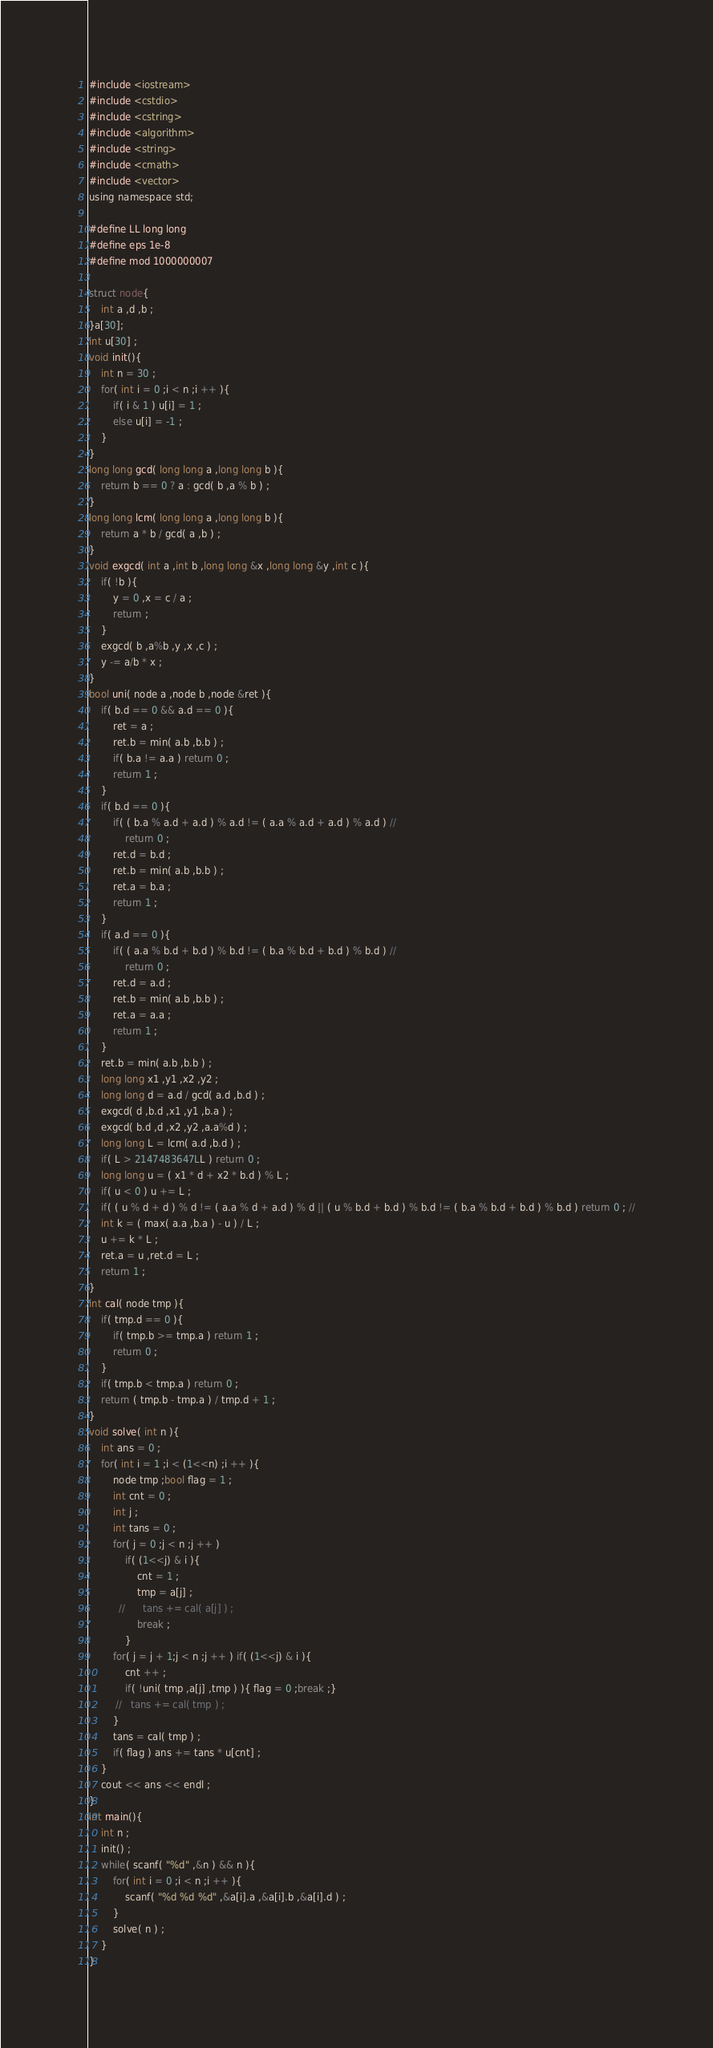<code> <loc_0><loc_0><loc_500><loc_500><_C_>








#include <iostream>
#include <cstdio>
#include <cstring>
#include <algorithm>
#include <string>
#include <cmath>
#include <vector>
using namespace std;

#define LL long long
#define eps 1e-8
#define mod 1000000007

struct node{
    int a ,d ,b ;
}a[30];
int u[30] ;
void init(){
    int n = 30 ;
    for( int i = 0 ;i < n ;i ++ ){
        if( i & 1 ) u[i] = 1 ;
        else u[i] = -1 ;
    }
}
long long gcd( long long a ,long long b ){
    return b == 0 ? a : gcd( b ,a % b ) ;
}
long long lcm( long long a ,long long b ){
    return a * b / gcd( a ,b ) ;
}
void exgcd( int a ,int b ,long long &x ,long long &y ,int c ){
    if( !b ){
        y = 0 ,x = c / a ;
        return ;
    }
    exgcd( b ,a%b ,y ,x ,c ) ;
    y -= a/b * x ;
}
bool uni( node a ,node b ,node &ret ){
    if( b.d == 0 && a.d == 0 ){
        ret = a ;
        ret.b = min( a.b ,b.b ) ;
        if( b.a != a.a ) return 0 ;
        return 1 ;
    }
    if( b.d == 0 ){
        if( ( b.a % a.d + a.d ) % a.d != ( a.a % a.d + a.d ) % a.d ) //
            return 0 ;
        ret.d = b.d ;
        ret.b = min( a.b ,b.b ) ;
        ret.a = b.a ;
        return 1 ;
    }
    if( a.d == 0 ){
        if( ( a.a % b.d + b.d ) % b.d != ( b.a % b.d + b.d ) % b.d ) //
            return 0 ;
        ret.d = a.d ;
        ret.b = min( a.b ,b.b ) ;
        ret.a = a.a ;
        return 1 ;
    }
    ret.b = min( a.b ,b.b ) ;
    long long x1 ,y1 ,x2 ,y2 ;
    long long d = a.d / gcd( a.d ,b.d ) ;
    exgcd( d ,b.d ,x1 ,y1 ,b.a ) ;
    exgcd( b.d ,d ,x2 ,y2 ,a.a%d ) ;
    long long L = lcm( a.d ,b.d ) ;
    if( L > 2147483647LL ) return 0 ;
    long long u = ( x1 * d + x2 * b.d ) % L ;
    if( u < 0 ) u += L ;
    if( ( u % d + d ) % d != ( a.a % d + a.d ) % d || ( u % b.d + b.d ) % b.d != ( b.a % b.d + b.d ) % b.d ) return 0 ; //
    int k = ( max( a.a ,b.a ) - u ) / L ;
    u += k * L ;
    ret.a = u ,ret.d = L ;
    return 1 ;
}
int cal( node tmp ){ 
    if( tmp.d == 0 ){
        if( tmp.b >= tmp.a ) return 1 ;
        return 0 ;
    }
    if( tmp.b < tmp.a ) return 0 ;
    return ( tmp.b - tmp.a ) / tmp.d + 1 ;
}
void solve( int n ){
    int ans = 0 ;
    for( int i = 1 ;i < (1<<n) ;i ++ ){
        node tmp ;bool flag = 1 ;
        int cnt = 0 ;
        int j ;
        int tans = 0 ;
        for( j = 0 ;j < n ;j ++ )
            if( (1<<j) & i ){
                cnt = 1 ;
                tmp = a[j] ;
          //      tans += cal( a[j] ) ;
                break ;
            }
        for( j = j + 1;j < n ;j ++ ) if( (1<<j) & i ){
            cnt ++ ;
            if( !uni( tmp ,a[j] ,tmp ) ){ flag = 0 ;break ;}
         //   tans += cal( tmp ) ;
        }
        tans = cal( tmp ) ;
        if( flag ) ans += tans * u[cnt] ;
    }
    cout << ans << endl ;
}
int main(){
    int n ;
    init() ;
    while( scanf( "%d" ,&n ) && n ){
        for( int i = 0 ;i < n ;i ++ ){
            scanf( "%d %d %d" ,&a[i].a ,&a[i].b ,&a[i].d ) ;
        }
        solve( n ) ;
    }
}</code> 